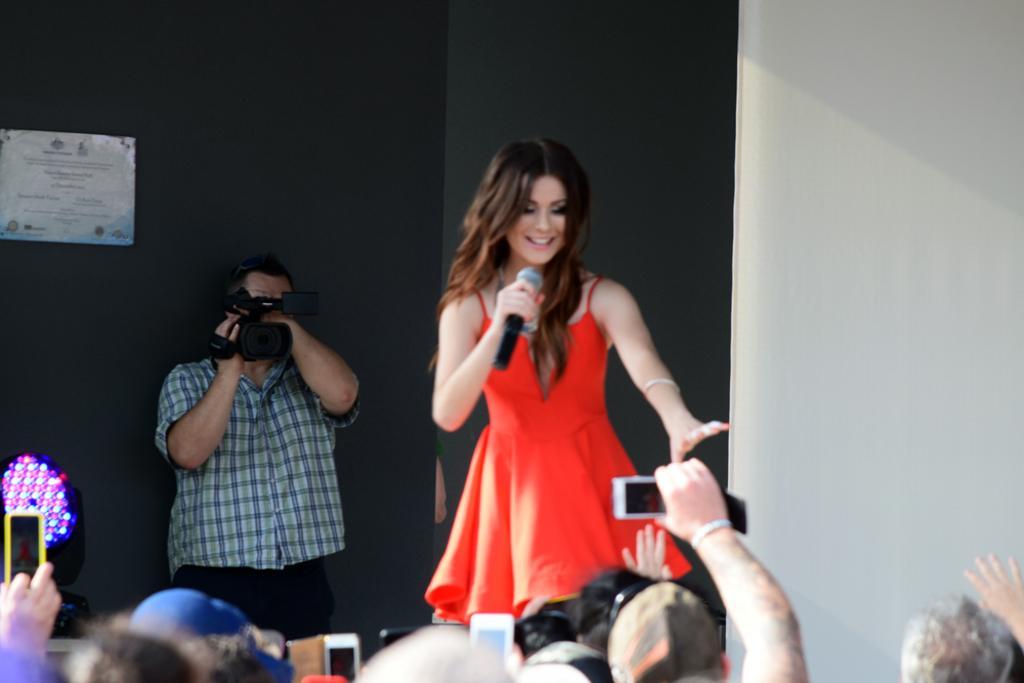Could you give a brief overview of what you see in this image? A woman is speaking with a mic in her hand and the people are taking pictures of her. 